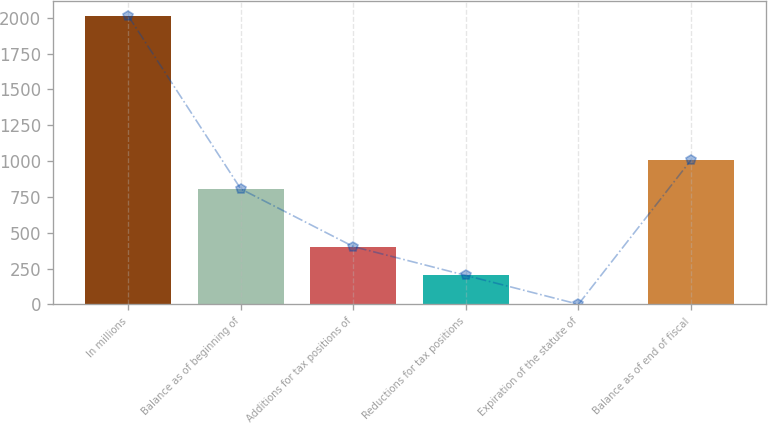Convert chart to OTSL. <chart><loc_0><loc_0><loc_500><loc_500><bar_chart><fcel>In millions<fcel>Balance as of beginning of<fcel>Additions for tax positions of<fcel>Reductions for tax positions<fcel>Expiration of the statute of<fcel>Balance as of end of fiscal<nl><fcel>2014<fcel>805.78<fcel>403.04<fcel>201.67<fcel>0.3<fcel>1007.15<nl></chart> 